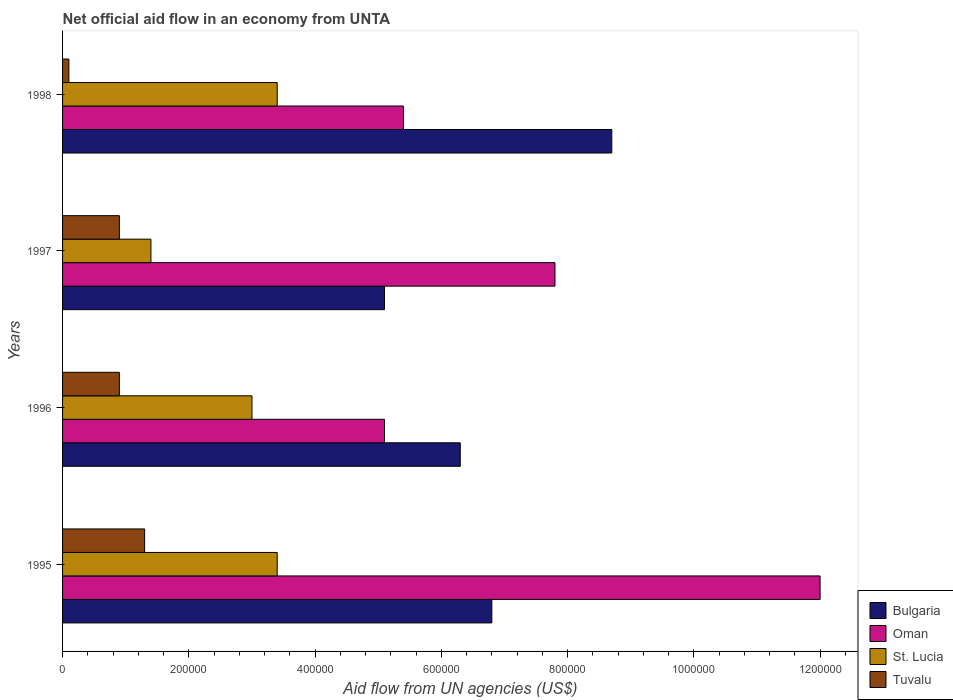How many different coloured bars are there?
Offer a very short reply. 4. How many groups of bars are there?
Give a very brief answer. 4. Are the number of bars per tick equal to the number of legend labels?
Offer a very short reply. Yes. How many bars are there on the 4th tick from the top?
Make the answer very short. 4. What is the label of the 3rd group of bars from the top?
Make the answer very short. 1996. In how many cases, is the number of bars for a given year not equal to the number of legend labels?
Keep it short and to the point. 0. What is the net official aid flow in Oman in 1995?
Make the answer very short. 1.20e+06. Across all years, what is the maximum net official aid flow in Bulgaria?
Ensure brevity in your answer.  8.70e+05. Across all years, what is the minimum net official aid flow in Bulgaria?
Make the answer very short. 5.10e+05. In which year was the net official aid flow in Oman minimum?
Provide a succinct answer. 1996. What is the total net official aid flow in Oman in the graph?
Keep it short and to the point. 3.03e+06. What is the difference between the net official aid flow in Bulgaria in 1995 and that in 1997?
Your response must be concise. 1.70e+05. In the year 1995, what is the difference between the net official aid flow in Bulgaria and net official aid flow in St. Lucia?
Provide a succinct answer. 3.40e+05. What is the ratio of the net official aid flow in Tuvalu in 1996 to that in 1997?
Your answer should be very brief. 1. Is the net official aid flow in Oman in 1996 less than that in 1997?
Your response must be concise. Yes. Is the difference between the net official aid flow in Bulgaria in 1997 and 1998 greater than the difference between the net official aid flow in St. Lucia in 1997 and 1998?
Your answer should be very brief. No. What is the difference between the highest and the lowest net official aid flow in Oman?
Provide a short and direct response. 6.90e+05. In how many years, is the net official aid flow in St. Lucia greater than the average net official aid flow in St. Lucia taken over all years?
Offer a terse response. 3. What does the 2nd bar from the top in 1997 represents?
Your answer should be very brief. St. Lucia. What does the 1st bar from the bottom in 1998 represents?
Your answer should be very brief. Bulgaria. How many bars are there?
Provide a short and direct response. 16. Are all the bars in the graph horizontal?
Offer a terse response. Yes. Does the graph contain any zero values?
Your response must be concise. No. Does the graph contain grids?
Offer a very short reply. No. Where does the legend appear in the graph?
Your response must be concise. Bottom right. How are the legend labels stacked?
Your response must be concise. Vertical. What is the title of the graph?
Provide a short and direct response. Net official aid flow in an economy from UNTA. What is the label or title of the X-axis?
Provide a succinct answer. Aid flow from UN agencies (US$). What is the label or title of the Y-axis?
Your answer should be compact. Years. What is the Aid flow from UN agencies (US$) in Bulgaria in 1995?
Provide a short and direct response. 6.80e+05. What is the Aid flow from UN agencies (US$) of Oman in 1995?
Your answer should be compact. 1.20e+06. What is the Aid flow from UN agencies (US$) in Bulgaria in 1996?
Provide a short and direct response. 6.30e+05. What is the Aid flow from UN agencies (US$) of Oman in 1996?
Give a very brief answer. 5.10e+05. What is the Aid flow from UN agencies (US$) of Tuvalu in 1996?
Your response must be concise. 9.00e+04. What is the Aid flow from UN agencies (US$) of Bulgaria in 1997?
Give a very brief answer. 5.10e+05. What is the Aid flow from UN agencies (US$) of Oman in 1997?
Make the answer very short. 7.80e+05. What is the Aid flow from UN agencies (US$) of Bulgaria in 1998?
Your answer should be very brief. 8.70e+05. What is the Aid flow from UN agencies (US$) in Oman in 1998?
Give a very brief answer. 5.40e+05. What is the Aid flow from UN agencies (US$) in St. Lucia in 1998?
Make the answer very short. 3.40e+05. Across all years, what is the maximum Aid flow from UN agencies (US$) of Bulgaria?
Provide a short and direct response. 8.70e+05. Across all years, what is the maximum Aid flow from UN agencies (US$) in Oman?
Your answer should be compact. 1.20e+06. Across all years, what is the maximum Aid flow from UN agencies (US$) of Tuvalu?
Ensure brevity in your answer.  1.30e+05. Across all years, what is the minimum Aid flow from UN agencies (US$) in Bulgaria?
Offer a terse response. 5.10e+05. Across all years, what is the minimum Aid flow from UN agencies (US$) in Oman?
Offer a very short reply. 5.10e+05. Across all years, what is the minimum Aid flow from UN agencies (US$) in St. Lucia?
Offer a very short reply. 1.40e+05. What is the total Aid flow from UN agencies (US$) of Bulgaria in the graph?
Give a very brief answer. 2.69e+06. What is the total Aid flow from UN agencies (US$) of Oman in the graph?
Your answer should be very brief. 3.03e+06. What is the total Aid flow from UN agencies (US$) in St. Lucia in the graph?
Your answer should be compact. 1.12e+06. What is the difference between the Aid flow from UN agencies (US$) in Oman in 1995 and that in 1996?
Keep it short and to the point. 6.90e+05. What is the difference between the Aid flow from UN agencies (US$) in St. Lucia in 1995 and that in 1996?
Ensure brevity in your answer.  4.00e+04. What is the difference between the Aid flow from UN agencies (US$) in Bulgaria in 1995 and that in 1997?
Your answer should be very brief. 1.70e+05. What is the difference between the Aid flow from UN agencies (US$) in Tuvalu in 1995 and that in 1997?
Provide a succinct answer. 4.00e+04. What is the difference between the Aid flow from UN agencies (US$) of Oman in 1995 and that in 1998?
Offer a very short reply. 6.60e+05. What is the difference between the Aid flow from UN agencies (US$) in St. Lucia in 1995 and that in 1998?
Offer a very short reply. 0. What is the difference between the Aid flow from UN agencies (US$) in Tuvalu in 1996 and that in 1997?
Your response must be concise. 0. What is the difference between the Aid flow from UN agencies (US$) of Bulgaria in 1996 and that in 1998?
Provide a succinct answer. -2.40e+05. What is the difference between the Aid flow from UN agencies (US$) in Bulgaria in 1997 and that in 1998?
Provide a succinct answer. -3.60e+05. What is the difference between the Aid flow from UN agencies (US$) in Oman in 1997 and that in 1998?
Provide a succinct answer. 2.40e+05. What is the difference between the Aid flow from UN agencies (US$) in St. Lucia in 1997 and that in 1998?
Provide a short and direct response. -2.00e+05. What is the difference between the Aid flow from UN agencies (US$) of Tuvalu in 1997 and that in 1998?
Provide a short and direct response. 8.00e+04. What is the difference between the Aid flow from UN agencies (US$) of Bulgaria in 1995 and the Aid flow from UN agencies (US$) of St. Lucia in 1996?
Offer a very short reply. 3.80e+05. What is the difference between the Aid flow from UN agencies (US$) of Bulgaria in 1995 and the Aid flow from UN agencies (US$) of Tuvalu in 1996?
Provide a short and direct response. 5.90e+05. What is the difference between the Aid flow from UN agencies (US$) in Oman in 1995 and the Aid flow from UN agencies (US$) in Tuvalu in 1996?
Your answer should be very brief. 1.11e+06. What is the difference between the Aid flow from UN agencies (US$) in Bulgaria in 1995 and the Aid flow from UN agencies (US$) in St. Lucia in 1997?
Ensure brevity in your answer.  5.40e+05. What is the difference between the Aid flow from UN agencies (US$) in Bulgaria in 1995 and the Aid flow from UN agencies (US$) in Tuvalu in 1997?
Keep it short and to the point. 5.90e+05. What is the difference between the Aid flow from UN agencies (US$) in Oman in 1995 and the Aid flow from UN agencies (US$) in St. Lucia in 1997?
Your answer should be compact. 1.06e+06. What is the difference between the Aid flow from UN agencies (US$) in Oman in 1995 and the Aid flow from UN agencies (US$) in Tuvalu in 1997?
Provide a succinct answer. 1.11e+06. What is the difference between the Aid flow from UN agencies (US$) in St. Lucia in 1995 and the Aid flow from UN agencies (US$) in Tuvalu in 1997?
Offer a very short reply. 2.50e+05. What is the difference between the Aid flow from UN agencies (US$) in Bulgaria in 1995 and the Aid flow from UN agencies (US$) in Oman in 1998?
Provide a succinct answer. 1.40e+05. What is the difference between the Aid flow from UN agencies (US$) in Bulgaria in 1995 and the Aid flow from UN agencies (US$) in St. Lucia in 1998?
Your response must be concise. 3.40e+05. What is the difference between the Aid flow from UN agencies (US$) of Bulgaria in 1995 and the Aid flow from UN agencies (US$) of Tuvalu in 1998?
Give a very brief answer. 6.70e+05. What is the difference between the Aid flow from UN agencies (US$) of Oman in 1995 and the Aid flow from UN agencies (US$) of St. Lucia in 1998?
Provide a short and direct response. 8.60e+05. What is the difference between the Aid flow from UN agencies (US$) in Oman in 1995 and the Aid flow from UN agencies (US$) in Tuvalu in 1998?
Ensure brevity in your answer.  1.19e+06. What is the difference between the Aid flow from UN agencies (US$) in St. Lucia in 1995 and the Aid flow from UN agencies (US$) in Tuvalu in 1998?
Your answer should be compact. 3.30e+05. What is the difference between the Aid flow from UN agencies (US$) of Bulgaria in 1996 and the Aid flow from UN agencies (US$) of Tuvalu in 1997?
Offer a very short reply. 5.40e+05. What is the difference between the Aid flow from UN agencies (US$) of Oman in 1996 and the Aid flow from UN agencies (US$) of St. Lucia in 1997?
Ensure brevity in your answer.  3.70e+05. What is the difference between the Aid flow from UN agencies (US$) of St. Lucia in 1996 and the Aid flow from UN agencies (US$) of Tuvalu in 1997?
Keep it short and to the point. 2.10e+05. What is the difference between the Aid flow from UN agencies (US$) of Bulgaria in 1996 and the Aid flow from UN agencies (US$) of Tuvalu in 1998?
Your answer should be compact. 6.20e+05. What is the difference between the Aid flow from UN agencies (US$) of Oman in 1996 and the Aid flow from UN agencies (US$) of Tuvalu in 1998?
Keep it short and to the point. 5.00e+05. What is the difference between the Aid flow from UN agencies (US$) of Bulgaria in 1997 and the Aid flow from UN agencies (US$) of St. Lucia in 1998?
Offer a terse response. 1.70e+05. What is the difference between the Aid flow from UN agencies (US$) of Bulgaria in 1997 and the Aid flow from UN agencies (US$) of Tuvalu in 1998?
Provide a succinct answer. 5.00e+05. What is the difference between the Aid flow from UN agencies (US$) of Oman in 1997 and the Aid flow from UN agencies (US$) of Tuvalu in 1998?
Keep it short and to the point. 7.70e+05. What is the difference between the Aid flow from UN agencies (US$) of St. Lucia in 1997 and the Aid flow from UN agencies (US$) of Tuvalu in 1998?
Your answer should be very brief. 1.30e+05. What is the average Aid flow from UN agencies (US$) of Bulgaria per year?
Make the answer very short. 6.72e+05. What is the average Aid flow from UN agencies (US$) in Oman per year?
Make the answer very short. 7.58e+05. What is the average Aid flow from UN agencies (US$) of St. Lucia per year?
Your answer should be very brief. 2.80e+05. What is the average Aid flow from UN agencies (US$) in Tuvalu per year?
Give a very brief answer. 8.00e+04. In the year 1995, what is the difference between the Aid flow from UN agencies (US$) of Bulgaria and Aid flow from UN agencies (US$) of Oman?
Your answer should be very brief. -5.20e+05. In the year 1995, what is the difference between the Aid flow from UN agencies (US$) in Bulgaria and Aid flow from UN agencies (US$) in St. Lucia?
Offer a terse response. 3.40e+05. In the year 1995, what is the difference between the Aid flow from UN agencies (US$) of Oman and Aid flow from UN agencies (US$) of St. Lucia?
Provide a succinct answer. 8.60e+05. In the year 1995, what is the difference between the Aid flow from UN agencies (US$) of Oman and Aid flow from UN agencies (US$) of Tuvalu?
Your response must be concise. 1.07e+06. In the year 1995, what is the difference between the Aid flow from UN agencies (US$) in St. Lucia and Aid flow from UN agencies (US$) in Tuvalu?
Offer a very short reply. 2.10e+05. In the year 1996, what is the difference between the Aid flow from UN agencies (US$) of Bulgaria and Aid flow from UN agencies (US$) of St. Lucia?
Provide a short and direct response. 3.30e+05. In the year 1996, what is the difference between the Aid flow from UN agencies (US$) in Bulgaria and Aid flow from UN agencies (US$) in Tuvalu?
Offer a very short reply. 5.40e+05. In the year 1996, what is the difference between the Aid flow from UN agencies (US$) of Oman and Aid flow from UN agencies (US$) of Tuvalu?
Ensure brevity in your answer.  4.20e+05. In the year 1996, what is the difference between the Aid flow from UN agencies (US$) in St. Lucia and Aid flow from UN agencies (US$) in Tuvalu?
Give a very brief answer. 2.10e+05. In the year 1997, what is the difference between the Aid flow from UN agencies (US$) in Bulgaria and Aid flow from UN agencies (US$) in Tuvalu?
Ensure brevity in your answer.  4.20e+05. In the year 1997, what is the difference between the Aid flow from UN agencies (US$) of Oman and Aid flow from UN agencies (US$) of St. Lucia?
Ensure brevity in your answer.  6.40e+05. In the year 1997, what is the difference between the Aid flow from UN agencies (US$) in Oman and Aid flow from UN agencies (US$) in Tuvalu?
Your answer should be compact. 6.90e+05. In the year 1998, what is the difference between the Aid flow from UN agencies (US$) of Bulgaria and Aid flow from UN agencies (US$) of St. Lucia?
Offer a terse response. 5.30e+05. In the year 1998, what is the difference between the Aid flow from UN agencies (US$) of Bulgaria and Aid flow from UN agencies (US$) of Tuvalu?
Provide a succinct answer. 8.60e+05. In the year 1998, what is the difference between the Aid flow from UN agencies (US$) of Oman and Aid flow from UN agencies (US$) of St. Lucia?
Give a very brief answer. 2.00e+05. In the year 1998, what is the difference between the Aid flow from UN agencies (US$) of Oman and Aid flow from UN agencies (US$) of Tuvalu?
Make the answer very short. 5.30e+05. What is the ratio of the Aid flow from UN agencies (US$) of Bulgaria in 1995 to that in 1996?
Your answer should be very brief. 1.08. What is the ratio of the Aid flow from UN agencies (US$) of Oman in 1995 to that in 1996?
Ensure brevity in your answer.  2.35. What is the ratio of the Aid flow from UN agencies (US$) in St. Lucia in 1995 to that in 1996?
Your answer should be compact. 1.13. What is the ratio of the Aid flow from UN agencies (US$) of Tuvalu in 1995 to that in 1996?
Offer a terse response. 1.44. What is the ratio of the Aid flow from UN agencies (US$) in Oman in 1995 to that in 1997?
Give a very brief answer. 1.54. What is the ratio of the Aid flow from UN agencies (US$) in St. Lucia in 1995 to that in 1997?
Make the answer very short. 2.43. What is the ratio of the Aid flow from UN agencies (US$) in Tuvalu in 1995 to that in 1997?
Provide a short and direct response. 1.44. What is the ratio of the Aid flow from UN agencies (US$) in Bulgaria in 1995 to that in 1998?
Your response must be concise. 0.78. What is the ratio of the Aid flow from UN agencies (US$) of Oman in 1995 to that in 1998?
Make the answer very short. 2.22. What is the ratio of the Aid flow from UN agencies (US$) of St. Lucia in 1995 to that in 1998?
Your response must be concise. 1. What is the ratio of the Aid flow from UN agencies (US$) of Tuvalu in 1995 to that in 1998?
Keep it short and to the point. 13. What is the ratio of the Aid flow from UN agencies (US$) of Bulgaria in 1996 to that in 1997?
Your answer should be very brief. 1.24. What is the ratio of the Aid flow from UN agencies (US$) of Oman in 1996 to that in 1997?
Provide a short and direct response. 0.65. What is the ratio of the Aid flow from UN agencies (US$) in St. Lucia in 1996 to that in 1997?
Provide a short and direct response. 2.14. What is the ratio of the Aid flow from UN agencies (US$) in Tuvalu in 1996 to that in 1997?
Offer a very short reply. 1. What is the ratio of the Aid flow from UN agencies (US$) of Bulgaria in 1996 to that in 1998?
Your response must be concise. 0.72. What is the ratio of the Aid flow from UN agencies (US$) in St. Lucia in 1996 to that in 1998?
Offer a terse response. 0.88. What is the ratio of the Aid flow from UN agencies (US$) in Bulgaria in 1997 to that in 1998?
Your answer should be very brief. 0.59. What is the ratio of the Aid flow from UN agencies (US$) of Oman in 1997 to that in 1998?
Provide a short and direct response. 1.44. What is the ratio of the Aid flow from UN agencies (US$) of St. Lucia in 1997 to that in 1998?
Make the answer very short. 0.41. What is the difference between the highest and the second highest Aid flow from UN agencies (US$) in Tuvalu?
Your answer should be compact. 4.00e+04. What is the difference between the highest and the lowest Aid flow from UN agencies (US$) of Oman?
Offer a very short reply. 6.90e+05. What is the difference between the highest and the lowest Aid flow from UN agencies (US$) in St. Lucia?
Give a very brief answer. 2.00e+05. 